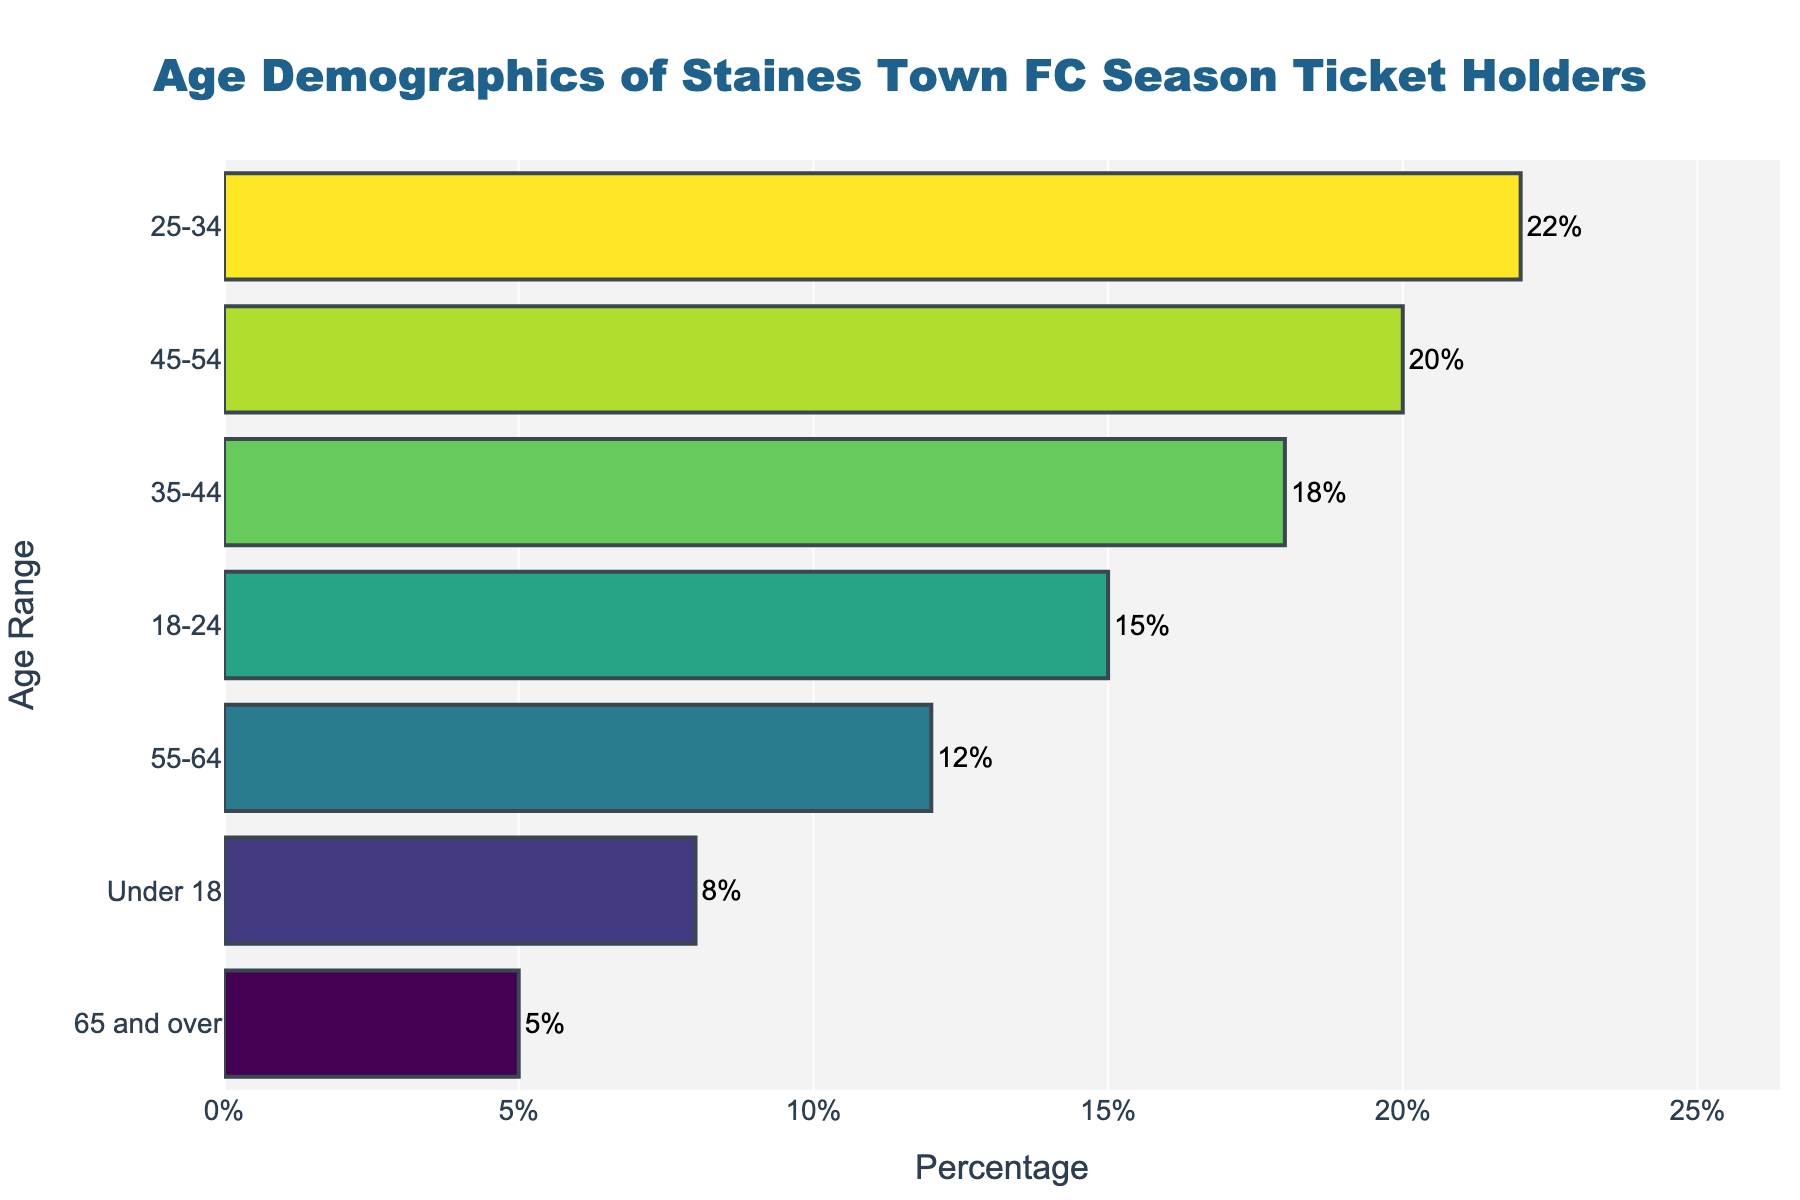How many age groups are listed in the plot? Count the number of unique age ranges shown on the y-axis.
Answer: 7 What is the title of the figure? Look at the top of the plot where the title is usually located.
Answer: Age Demographics of Staines Town FC Season Ticket Holders Which age group has the highest percentage of season ticket holders? Identify the bar with the largest value on the x-axis.
Answer: 25-34 How much higher is the percentage of season ticket holders in the 25-34 age group compared to the 65 and over group? Subtract the percentage of the 65 and over group from the percentage of the 25-34 group: 22% - 5% = 17%
Answer: 17% What is the combined percentage of season ticket holders aged between 18 and 44? Add the percentages of the 18-24 and 25-34 and 35-44 groups: 15% + 22% + 18% = 55%
Answer: 55% Which age group has the smallest percentage of season ticket holders? Identify the bar with the smallest value on the x-axis.
Answer: 65 and over Is the percentage of season ticket holders in the 55-64 age group higher than those in the Under 18 group? Compare the percentage values of the 55-64 and Under 18 groups: 12% > 8%
Answer: Yes What is the average percentage of season ticket holders across all age groups? Add all the percentage values and divide by the number of age groups: (8% + 15% + 22% + 18% + 20% + 12% + 5%) / 7 ≈ 14.29%
Answer: 14.29% Does any age group have exactly twice the percentage of another group? If yes, which one? Check each age group's percentage and see if doubling it matches any other group's percentage: The 8% of the Under 18 group doubled (16%) does not match any group. The 5% of the 65 and over group doubled (10%) also does not match any group. No other groups match this criteria.
Answer: No 